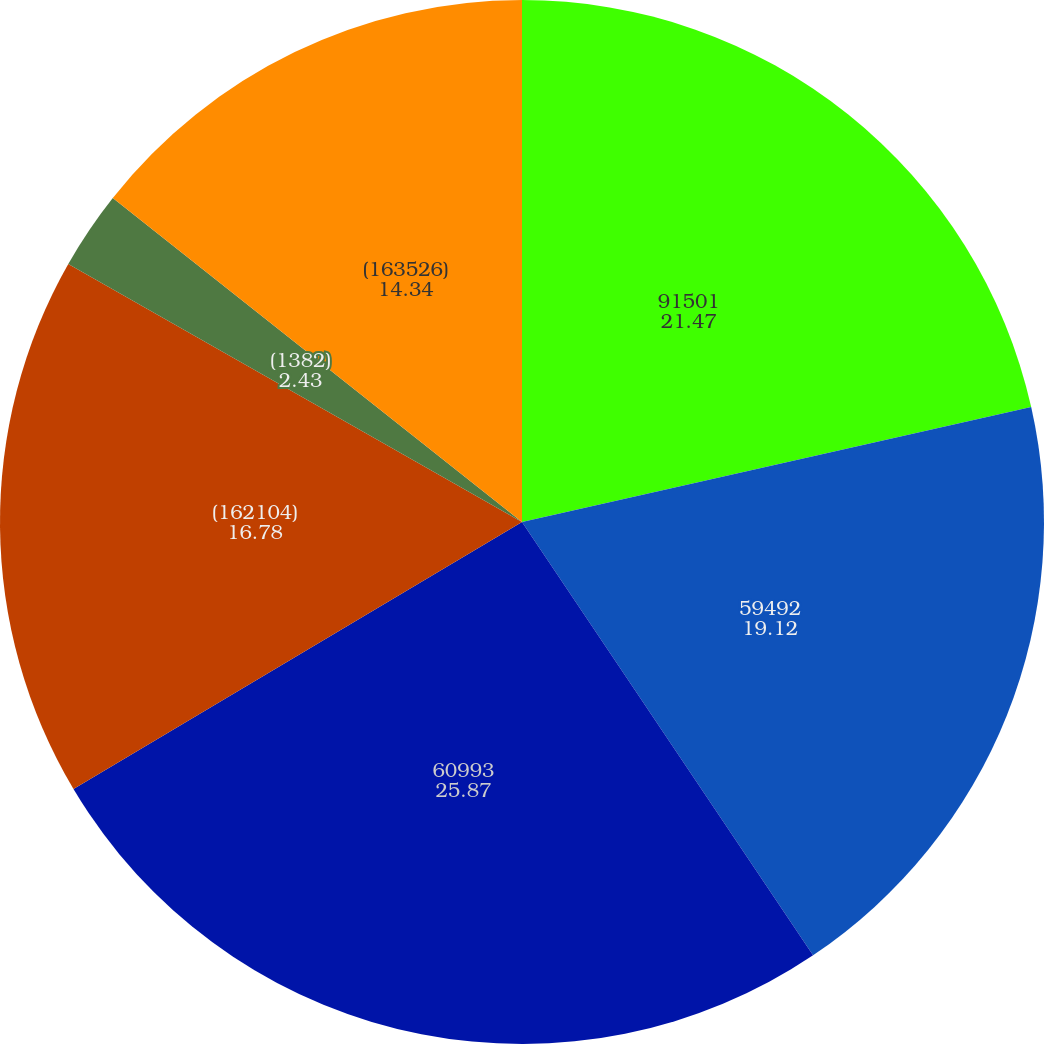Convert chart. <chart><loc_0><loc_0><loc_500><loc_500><pie_chart><fcel>91501<fcel>59492<fcel>60993<fcel>(162104)<fcel>(1382)<fcel>(163526)<nl><fcel>21.47%<fcel>19.12%<fcel>25.87%<fcel>16.78%<fcel>2.43%<fcel>14.34%<nl></chart> 